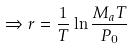<formula> <loc_0><loc_0><loc_500><loc_500>\Rightarrow r = \frac { 1 } { T } \ln \frac { M _ { a } T } { P _ { 0 } }</formula> 